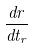<formula> <loc_0><loc_0><loc_500><loc_500>\frac { d r } { d t _ { r } }</formula> 